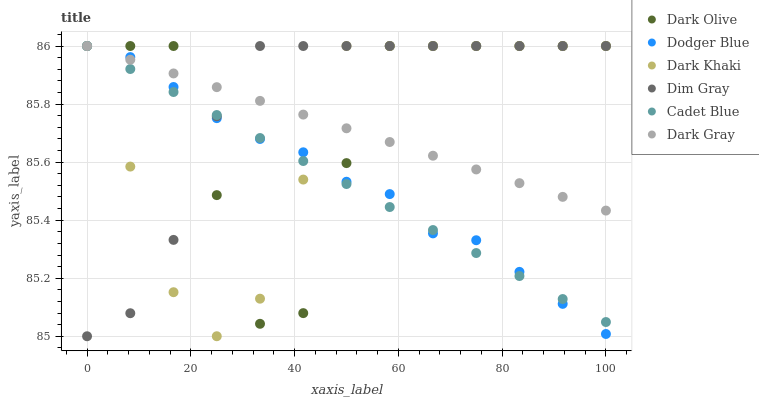Does Cadet Blue have the minimum area under the curve?
Answer yes or no. Yes. Does Dim Gray have the maximum area under the curve?
Answer yes or no. Yes. Does Dark Olive have the minimum area under the curve?
Answer yes or no. No. Does Dark Olive have the maximum area under the curve?
Answer yes or no. No. Is Cadet Blue the smoothest?
Answer yes or no. Yes. Is Dark Olive the roughest?
Answer yes or no. Yes. Is Dim Gray the smoothest?
Answer yes or no. No. Is Dim Gray the roughest?
Answer yes or no. No. Does Dim Gray have the lowest value?
Answer yes or no. Yes. Does Dark Olive have the lowest value?
Answer yes or no. No. Does Dodger Blue have the highest value?
Answer yes or no. Yes. Does Dark Khaki intersect Dark Olive?
Answer yes or no. Yes. Is Dark Khaki less than Dark Olive?
Answer yes or no. No. Is Dark Khaki greater than Dark Olive?
Answer yes or no. No. 